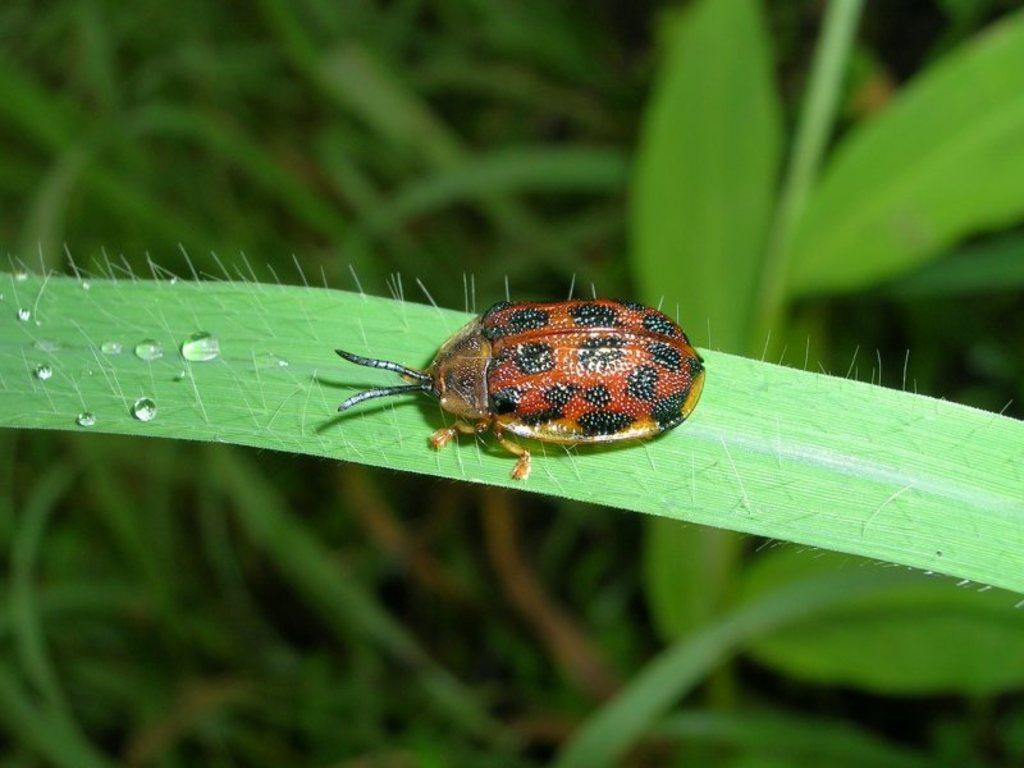Describe this image in one or two sentences. In the center of the image we can see a bug on the leaf. At the bottom there are plants. 